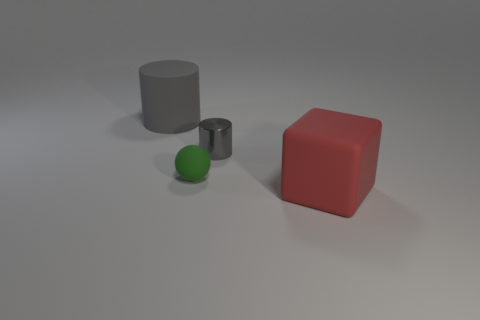Add 2 cylinders. How many objects exist? 6 Subtract all blocks. How many objects are left? 3 Subtract all small green matte balls. Subtract all rubber cylinders. How many objects are left? 2 Add 2 large gray things. How many large gray things are left? 3 Add 1 big green matte things. How many big green matte things exist? 1 Subtract 0 brown cubes. How many objects are left? 4 